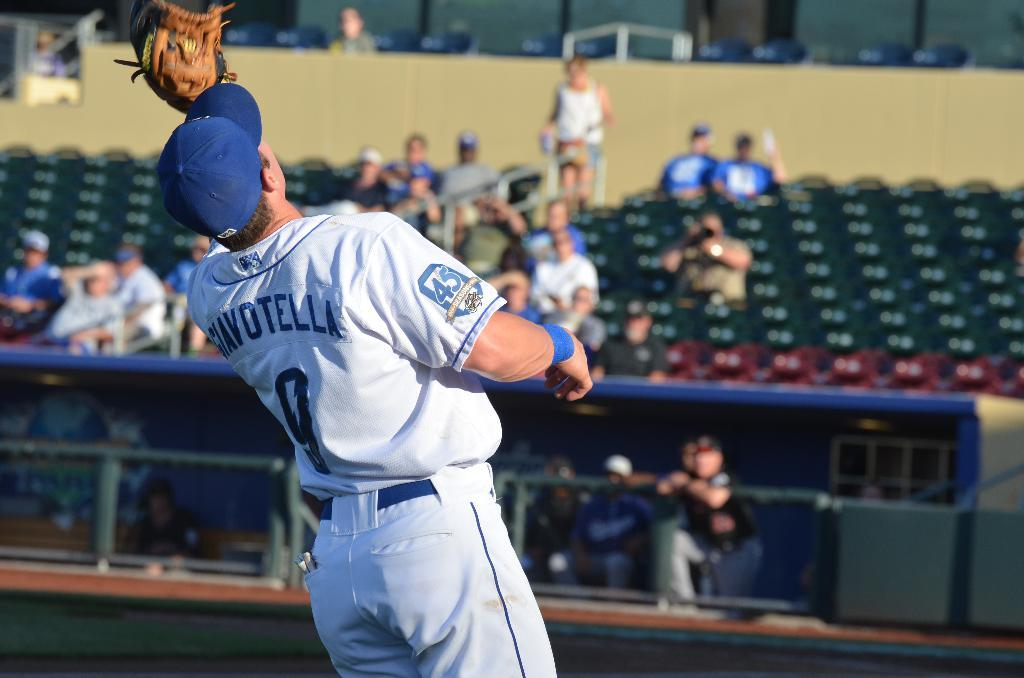<image>
Write a terse but informative summary of the picture. baseball player number 9 waiting to catch a ball and has 45 anniversary emblem on sleeve 